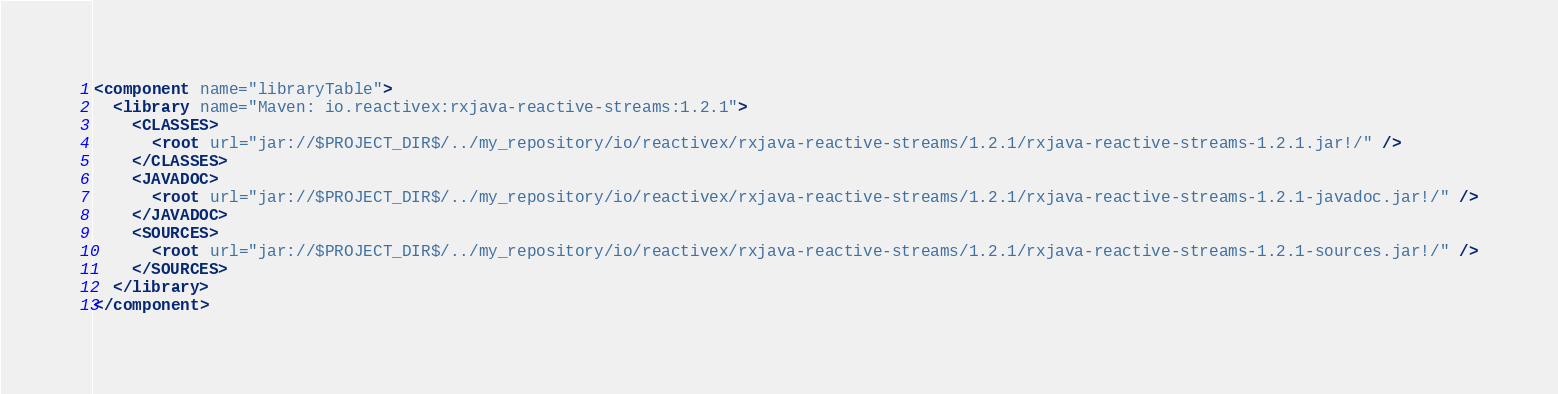Convert code to text. <code><loc_0><loc_0><loc_500><loc_500><_XML_><component name="libraryTable">
  <library name="Maven: io.reactivex:rxjava-reactive-streams:1.2.1">
    <CLASSES>
      <root url="jar://$PROJECT_DIR$/../my_repository/io/reactivex/rxjava-reactive-streams/1.2.1/rxjava-reactive-streams-1.2.1.jar!/" />
    </CLASSES>
    <JAVADOC>
      <root url="jar://$PROJECT_DIR$/../my_repository/io/reactivex/rxjava-reactive-streams/1.2.1/rxjava-reactive-streams-1.2.1-javadoc.jar!/" />
    </JAVADOC>
    <SOURCES>
      <root url="jar://$PROJECT_DIR$/../my_repository/io/reactivex/rxjava-reactive-streams/1.2.1/rxjava-reactive-streams-1.2.1-sources.jar!/" />
    </SOURCES>
  </library>
</component></code> 